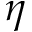Convert formula to latex. <formula><loc_0><loc_0><loc_500><loc_500>\eta</formula> 